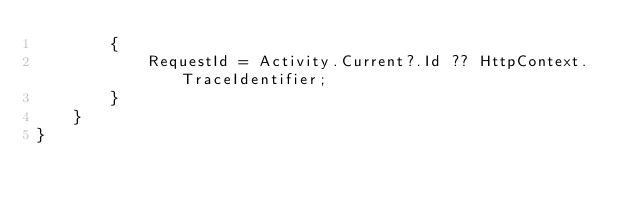<code> <loc_0><loc_0><loc_500><loc_500><_C#_>        {
            RequestId = Activity.Current?.Id ?? HttpContext.TraceIdentifier;
        }
    }
}
</code> 